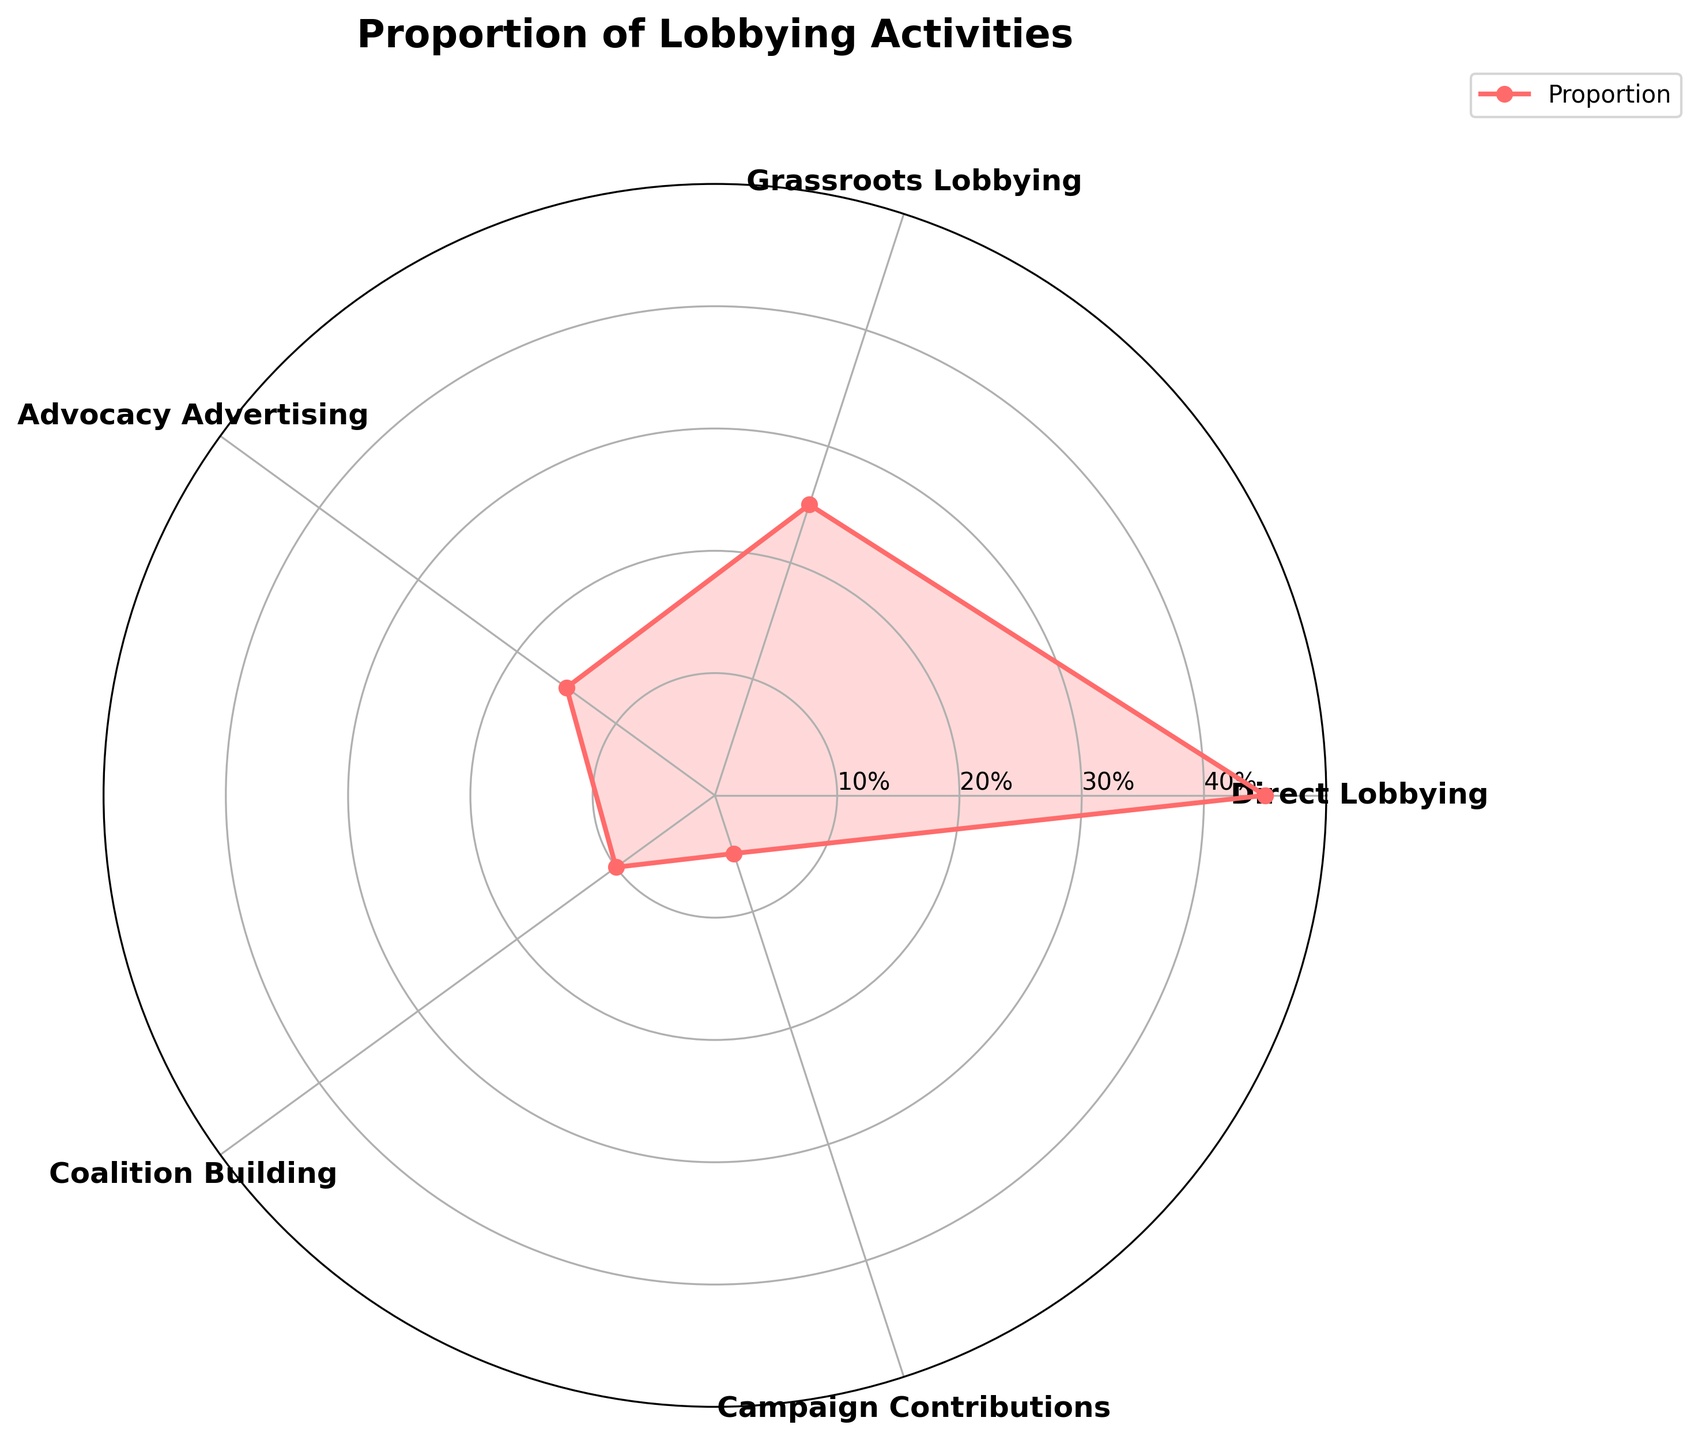What is the title of the figure? The title is usually prominently displayed at the top of the figure. In this case, the title is "Proportion of Lobbying Activities."
Answer: Proportion of Lobbying Activities How many types of lobbying activities are shown in the figure? The figure shows labeled segments for each type of lobbying activity. By counting the labels, we see there are 5 types: Direct Lobbying, Grassroots Lobbying, Advocacy Advertising, Coalition Building, and Campaign Contributions.
Answer: 5 Which lobbying activity has the highest proportion? By looking at the segments and their respective proportions, it's clear that Direct Lobbying has the largest segment, indicating the highest proportion at 45%.
Answer: Direct Lobbying What are the proportions of Coalition Building and Campaign Contributions combined? The proportions for Coalition Building and Campaign Contributions are 10% and 5%, respectively. Adding them together gives 10% + 5% = 15%.
Answer: 15% Which lobbying activity has a proportion that is one-third of Direct Lobbying? Direct Lobbying has a proportion of 45%. One-third of 45% is 15%. From the figure, Advocacy Advertising has a proportion of 15%, which matches.
Answer: Advocacy Advertising Comparing Grassroots Lobbying and Advocacy Advertising, which one has a greater proportion? From the figure, Grassroots Lobbying has a proportion of 25% while Advocacy Advertising has 15%. 25% is greater than 15%.
Answer: Grassroots Lobbying What is the difference in proportions between Direct Lobbying and Grassroots Lobbying? Direct Lobbying has a proportion of 45% and Grassroots Lobbying has 25%. The difference is 45% - 25% = 20%.
Answer: 20% What is the average proportion of all the lobbying activities? The proportions are 45%, 25%, 15%, 10%, and 5%. Adding these gives 100%. There are 5 activities, so the average is 100% / 5 = 20%.
Answer: 20% Which two activities together have the same proportion as Grassroots Lobbying? Grassroots Lobbying has a proportion of 25%. Coalition Building and Campaign Contributions have proportions of 10% and 5%, respectively. Adding them gives 10% + 5% = 15%, which isn't equal to 25%. However, Advocacy Advertising (15%) and Campaign Contributions (5%) added together equal 20%, which also does not match. The correct pair is Advocacy Advertising (15%) and Coalition Building (10%), giving a combined proportion of 25%, which matches Grassroots Lobbying.
Answer: Advocacy Advertising and Coalition Building How many angular segments are there in the Polar Chart if each type of lobbying activity is shown separately? Each type of lobbying activity is represented by one angular segment. Given there are 5 lobbying activities, there are 5 segments.
Answer: 5 